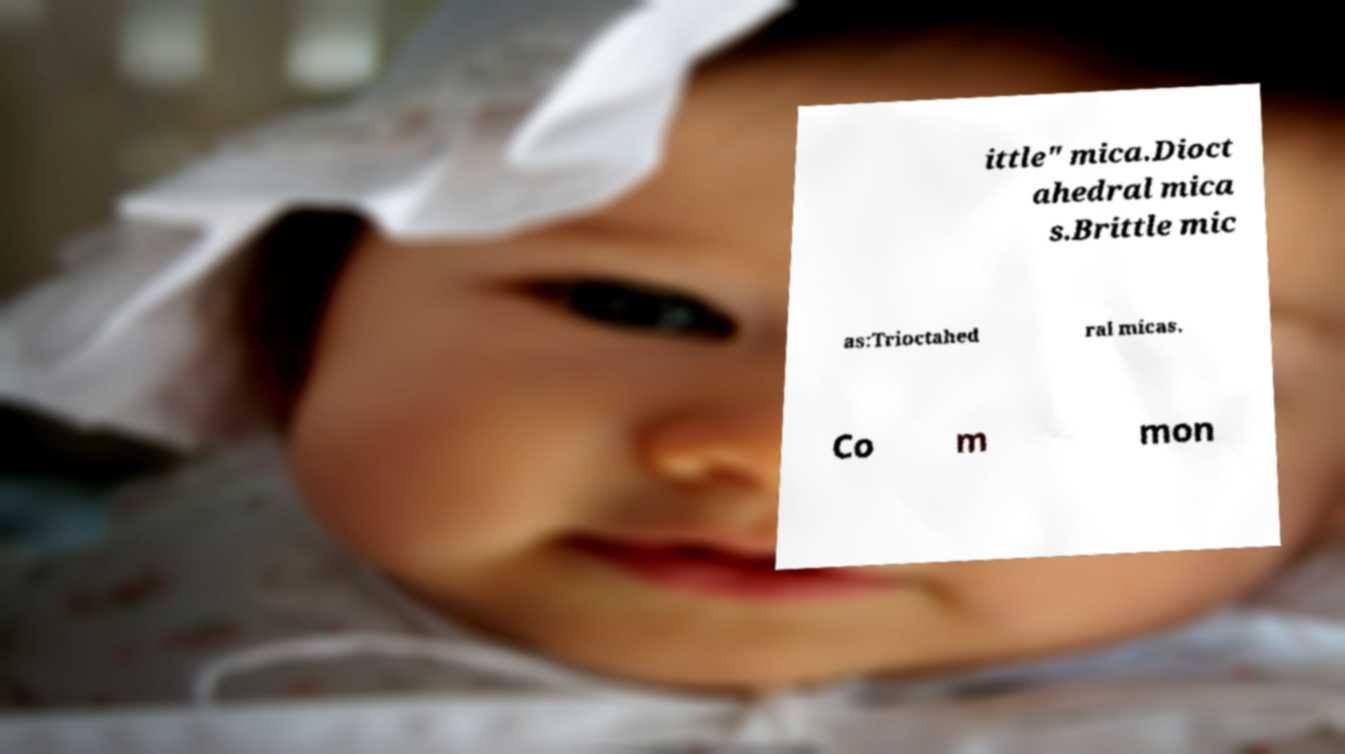Please identify and transcribe the text found in this image. ittle" mica.Dioct ahedral mica s.Brittle mic as:Trioctahed ral micas. Co m mon 